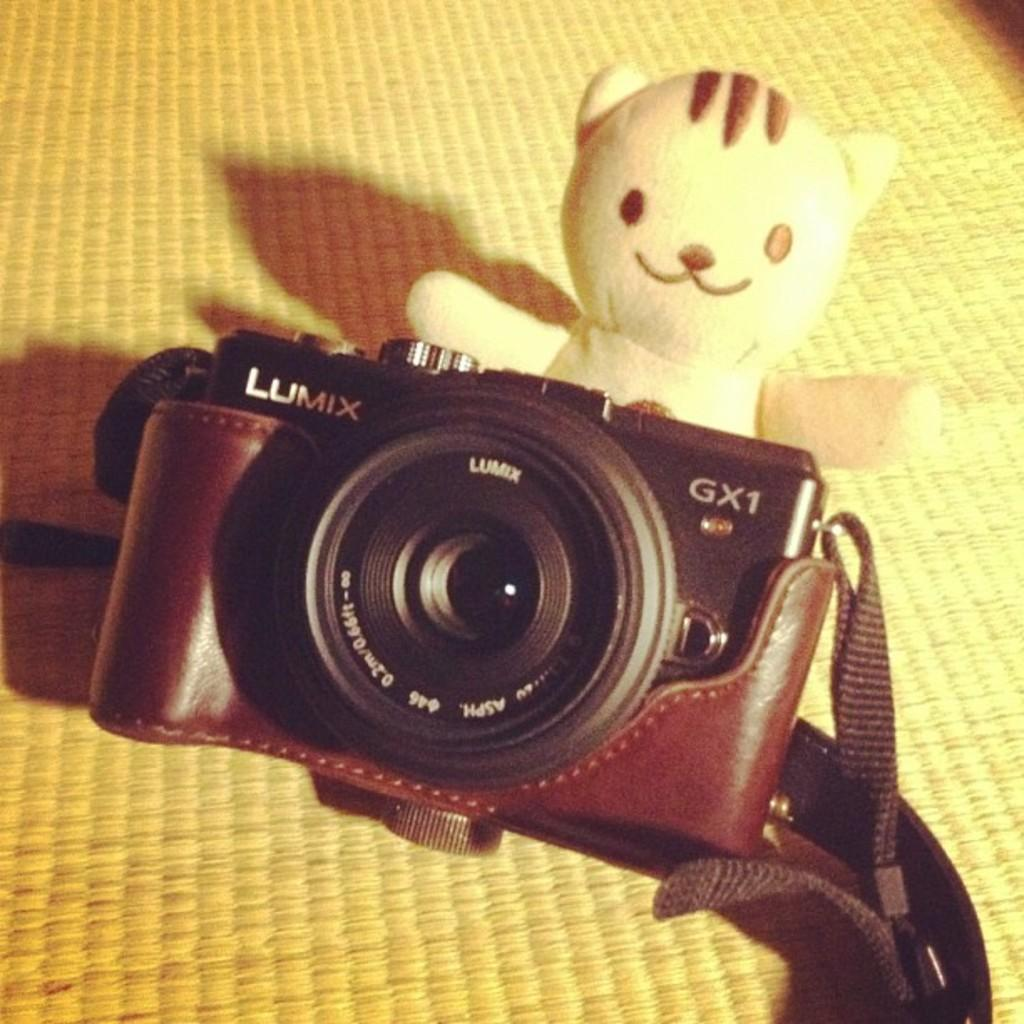What object is the main focus of the image? There is a doll in the center of the image. What other object can be seen in the image? There is a camera in the image. What type of substance is being emitted by the doll in the image? There is no substance being emitted by the doll in the image. How many bears are visible in the image? There are no bears present in the image. 